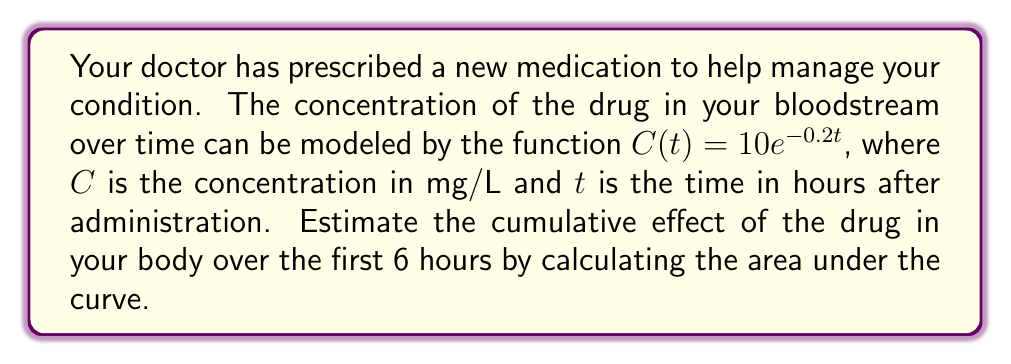Show me your answer to this math problem. To estimate the cumulative effect of the drug, we need to calculate the area under the curve (AUC) of the concentration function $C(t) = 10e^{-0.2t}$ from $t=0$ to $t=6$.

Step 1: Set up the definite integral
$$\text{AUC} = \int_0^6 10e^{-0.2t} dt$$

Step 2: Use the antiderivative of $e^{-at}$, which is $-\frac{1}{a}e^{-at}$
$$\text{AUC} = 10 \cdot \left[-5e^{-0.2t}\right]_0^6$$

Step 3: Evaluate the integral
$$\text{AUC} = 10 \cdot \left[-5e^{-0.2(6)} - (-5e^{-0.2(0)})\right]$$
$$\text{AUC} = 10 \cdot \left[-5e^{-1.2} - (-5)\right]$$
$$\text{AUC} = 10 \cdot \left[-5(0.301194) + 5\right]$$
$$\text{AUC} = 10 \cdot [3.494030]$$
$$\text{AUC} = 34.94030$$

Step 4: Round to two decimal places
$$\text{AUC} \approx 34.94 \text{ mg⋅h/L}$$

This value represents the cumulative effect of the drug in your body over the first 6 hours, measured in concentration-time units.
Answer: 34.94 mg⋅h/L 